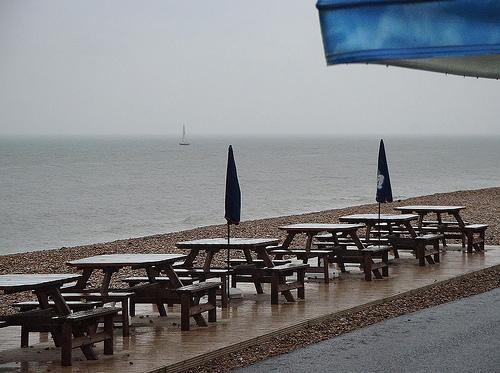What types of objects are on the ground, beneath and near the tables? Underneath and near the tables, there are pinecones, leaves, wet surfaces, and gravel. Describe the location and object placement in the image. The image features a beach scene with multiple picnic tables near the water, a closed beach umbrella, a sailboat on the water, and a bench behind a table. There's also a distinctive blue overhang near the water. What can you say about the state of the tables and the weather? The tables are empty with wet surfaces, suggesting that it's raining or has recently rained in the beach scene. Mention the color and the position of the overhang in the image. The overhang is blue in color and is positioned near the water in the upper part of the image. What characteristics can be observed about the ocean water? The ocean water is very calm with ripples and rough patches, hinting at a slight change in weather conditions. What objects are present in the water? In the water, there is a sailboat, boat, and ocean with calm waves and ripples. List the objects associated with the picnic tables. Some objects associated with the picnic tables are a closed beach umbrella, a white logo on a beach umbrella, pine cones underneath a table, wet surfaces, and leaves under the table. What types of furniture are placed on the patio? On the patio, there are wooden picnic tables, a bench by a table, a closed umbrella, and outdoor seating. Identify the colors and features of the beach umbrellas in the image. There is a blue and white beach umbrella with a white logo on it, and another closed beach umbrella. Describe the features observed in and around the raised area. The raised area has an aggregate on the side, gravel along the water and the road, and a fabric canopy with a blue porch roof over the water nearby. 